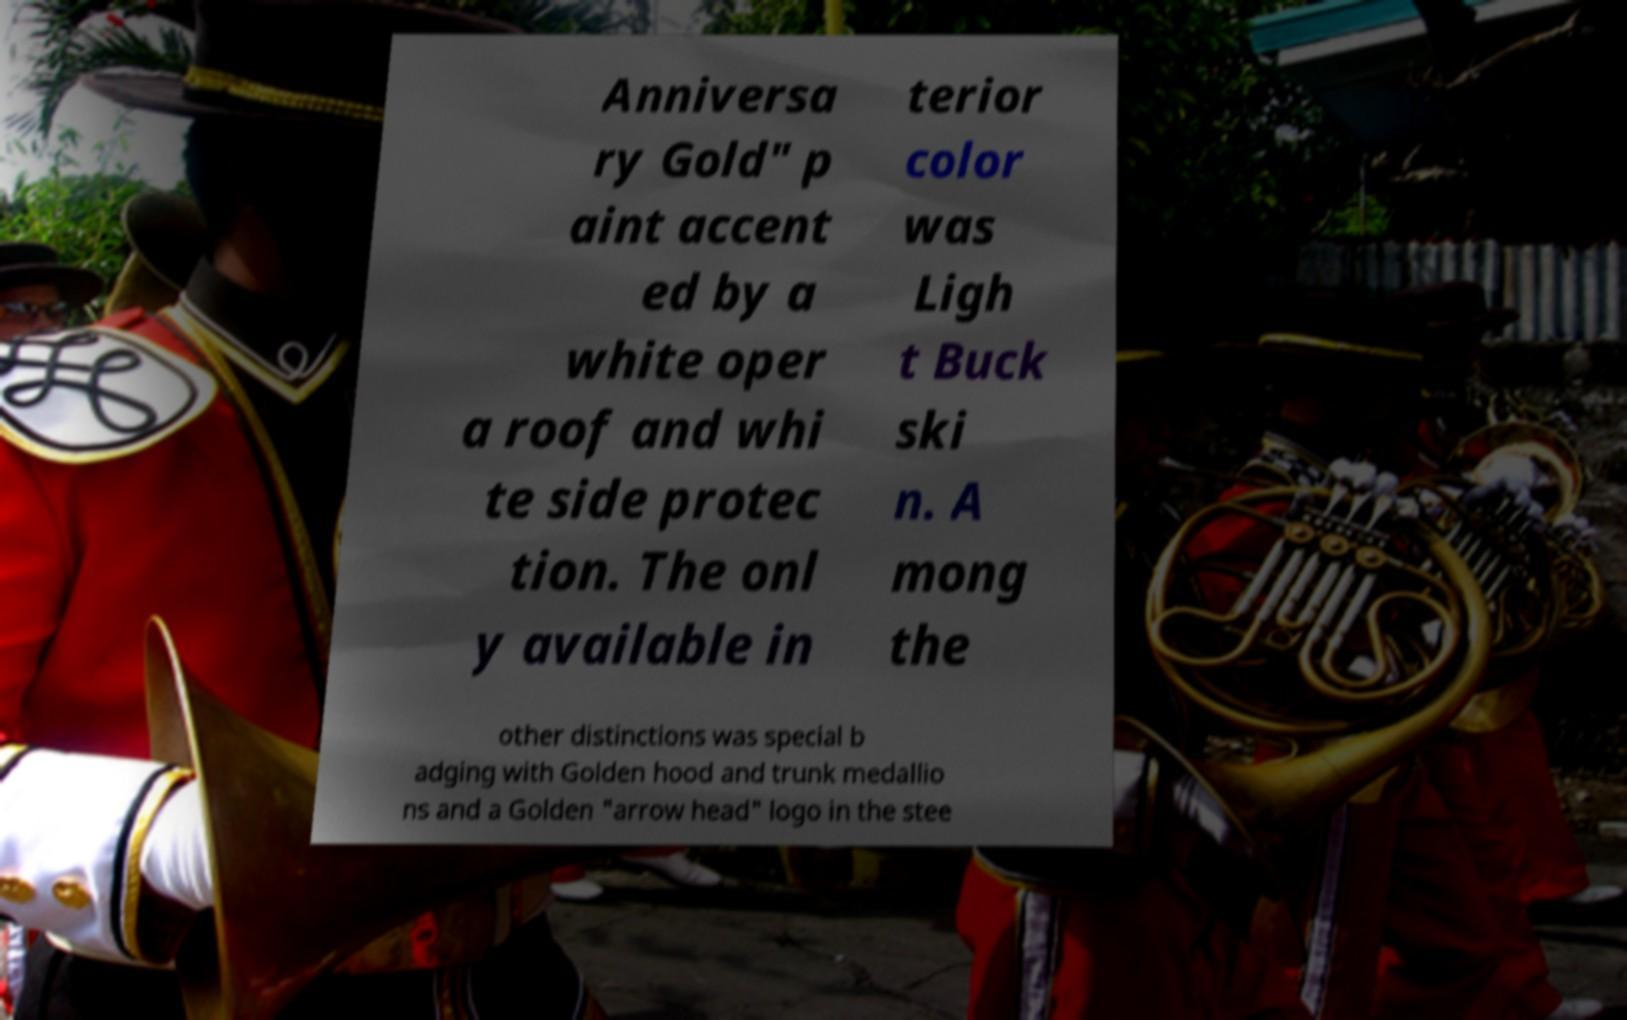For documentation purposes, I need the text within this image transcribed. Could you provide that? Anniversa ry Gold" p aint accent ed by a white oper a roof and whi te side protec tion. The onl y available in terior color was Ligh t Buck ski n. A mong the other distinctions was special b adging with Golden hood and trunk medallio ns and a Golden "arrow head" logo in the stee 